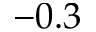<formula> <loc_0><loc_0><loc_500><loc_500>- 0 . 3</formula> 